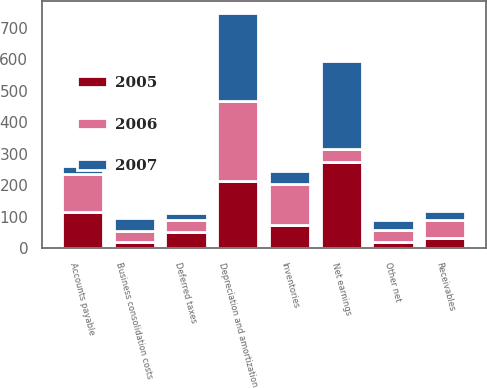Convert chart to OTSL. <chart><loc_0><loc_0><loc_500><loc_500><stacked_bar_chart><ecel><fcel>Net earnings<fcel>Depreciation and amortization<fcel>Business consolidation costs<fcel>Deferred taxes<fcel>Other net<fcel>Receivables<fcel>Inventories<fcel>Accounts payable<nl><fcel>2007<fcel>281.3<fcel>281<fcel>42.3<fcel>21<fcel>30.9<fcel>26.9<fcel>41<fcel>27.4<nl><fcel>2006<fcel>42.3<fcel>252.6<fcel>34.2<fcel>38.2<fcel>40.4<fcel>57<fcel>132.2<fcel>121.6<nl><fcel>2005<fcel>272.1<fcel>213.5<fcel>19<fcel>51.6<fcel>17.7<fcel>32.8<fcel>71.7<fcel>113.2<nl></chart> 